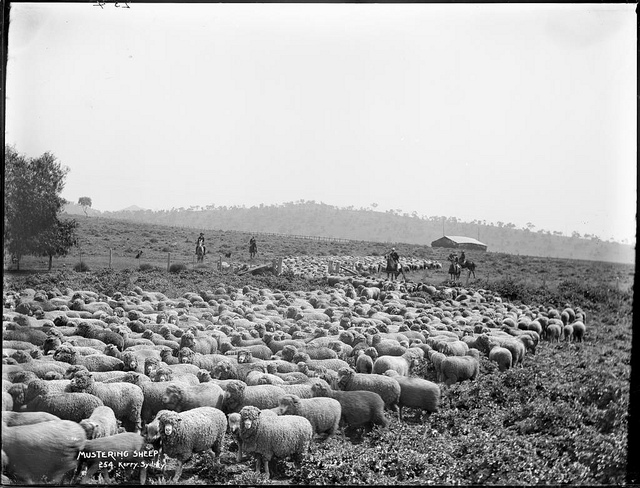Please extract the text content from this image. MUSTERING SHEEP 254 Kurry 